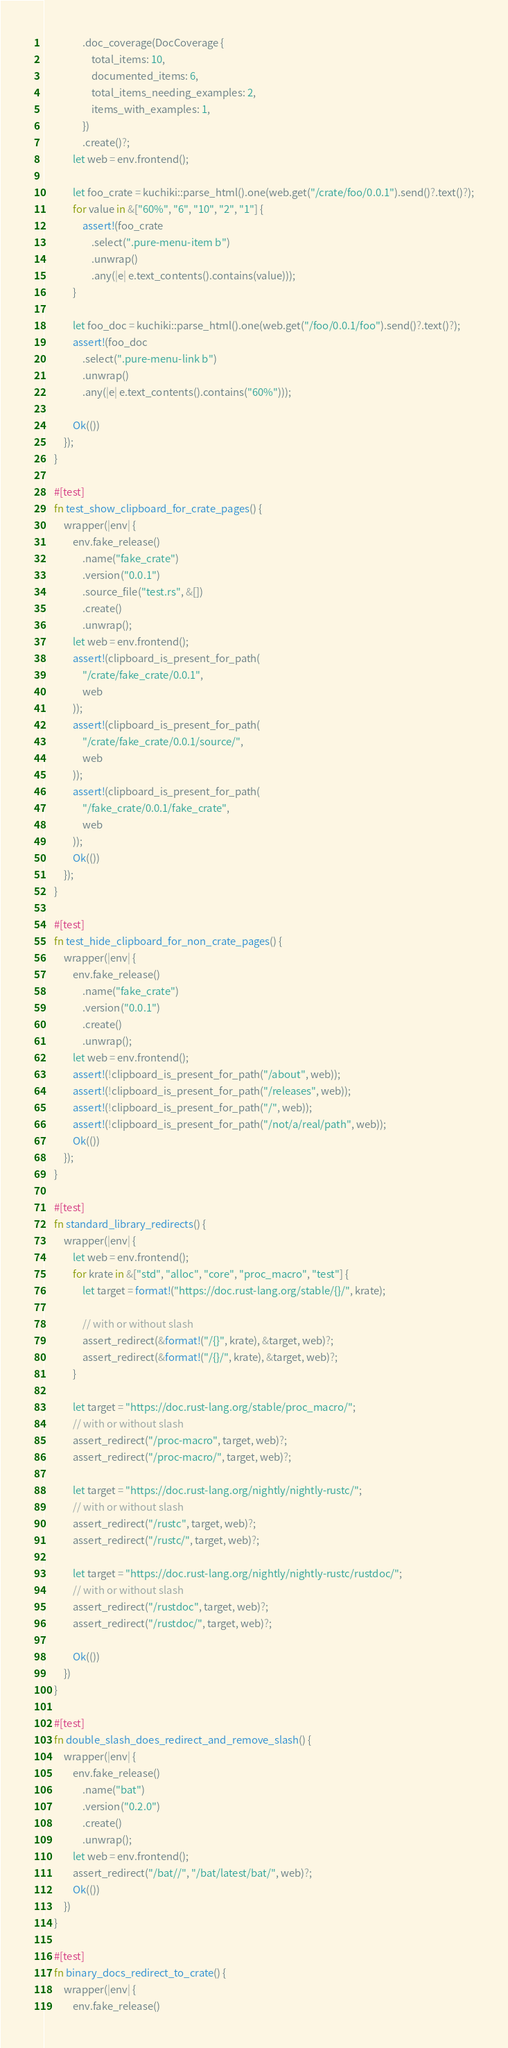Convert code to text. <code><loc_0><loc_0><loc_500><loc_500><_Rust_>                .doc_coverage(DocCoverage {
                    total_items: 10,
                    documented_items: 6,
                    total_items_needing_examples: 2,
                    items_with_examples: 1,
                })
                .create()?;
            let web = env.frontend();

            let foo_crate = kuchiki::parse_html().one(web.get("/crate/foo/0.0.1").send()?.text()?);
            for value in &["60%", "6", "10", "2", "1"] {
                assert!(foo_crate
                    .select(".pure-menu-item b")
                    .unwrap()
                    .any(|e| e.text_contents().contains(value)));
            }

            let foo_doc = kuchiki::parse_html().one(web.get("/foo/0.0.1/foo").send()?.text()?);
            assert!(foo_doc
                .select(".pure-menu-link b")
                .unwrap()
                .any(|e| e.text_contents().contains("60%")));

            Ok(())
        });
    }

    #[test]
    fn test_show_clipboard_for_crate_pages() {
        wrapper(|env| {
            env.fake_release()
                .name("fake_crate")
                .version("0.0.1")
                .source_file("test.rs", &[])
                .create()
                .unwrap();
            let web = env.frontend();
            assert!(clipboard_is_present_for_path(
                "/crate/fake_crate/0.0.1",
                web
            ));
            assert!(clipboard_is_present_for_path(
                "/crate/fake_crate/0.0.1/source/",
                web
            ));
            assert!(clipboard_is_present_for_path(
                "/fake_crate/0.0.1/fake_crate",
                web
            ));
            Ok(())
        });
    }

    #[test]
    fn test_hide_clipboard_for_non_crate_pages() {
        wrapper(|env| {
            env.fake_release()
                .name("fake_crate")
                .version("0.0.1")
                .create()
                .unwrap();
            let web = env.frontend();
            assert!(!clipboard_is_present_for_path("/about", web));
            assert!(!clipboard_is_present_for_path("/releases", web));
            assert!(!clipboard_is_present_for_path("/", web));
            assert!(!clipboard_is_present_for_path("/not/a/real/path", web));
            Ok(())
        });
    }

    #[test]
    fn standard_library_redirects() {
        wrapper(|env| {
            let web = env.frontend();
            for krate in &["std", "alloc", "core", "proc_macro", "test"] {
                let target = format!("https://doc.rust-lang.org/stable/{}/", krate);

                // with or without slash
                assert_redirect(&format!("/{}", krate), &target, web)?;
                assert_redirect(&format!("/{}/", krate), &target, web)?;
            }

            let target = "https://doc.rust-lang.org/stable/proc_macro/";
            // with or without slash
            assert_redirect("/proc-macro", target, web)?;
            assert_redirect("/proc-macro/", target, web)?;

            let target = "https://doc.rust-lang.org/nightly/nightly-rustc/";
            // with or without slash
            assert_redirect("/rustc", target, web)?;
            assert_redirect("/rustc/", target, web)?;

            let target = "https://doc.rust-lang.org/nightly/nightly-rustc/rustdoc/";
            // with or without slash
            assert_redirect("/rustdoc", target, web)?;
            assert_redirect("/rustdoc/", target, web)?;

            Ok(())
        })
    }

    #[test]
    fn double_slash_does_redirect_and_remove_slash() {
        wrapper(|env| {
            env.fake_release()
                .name("bat")
                .version("0.2.0")
                .create()
                .unwrap();
            let web = env.frontend();
            assert_redirect("/bat//", "/bat/latest/bat/", web)?;
            Ok(())
        })
    }

    #[test]
    fn binary_docs_redirect_to_crate() {
        wrapper(|env| {
            env.fake_release()</code> 